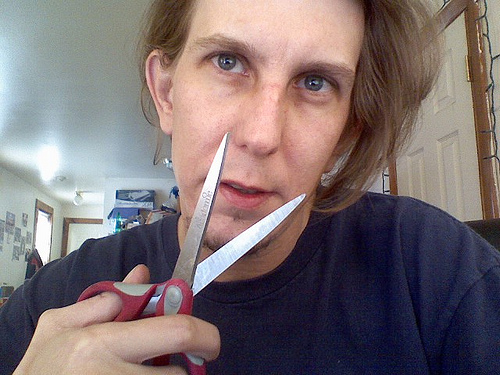Can you describe the setting in which this person is? The individual is indoors in a room that seems to be a living space, with wall decorations and various items in the background that suggest a domestic setting. There's a relaxed, informal atmosphere in the photo. 